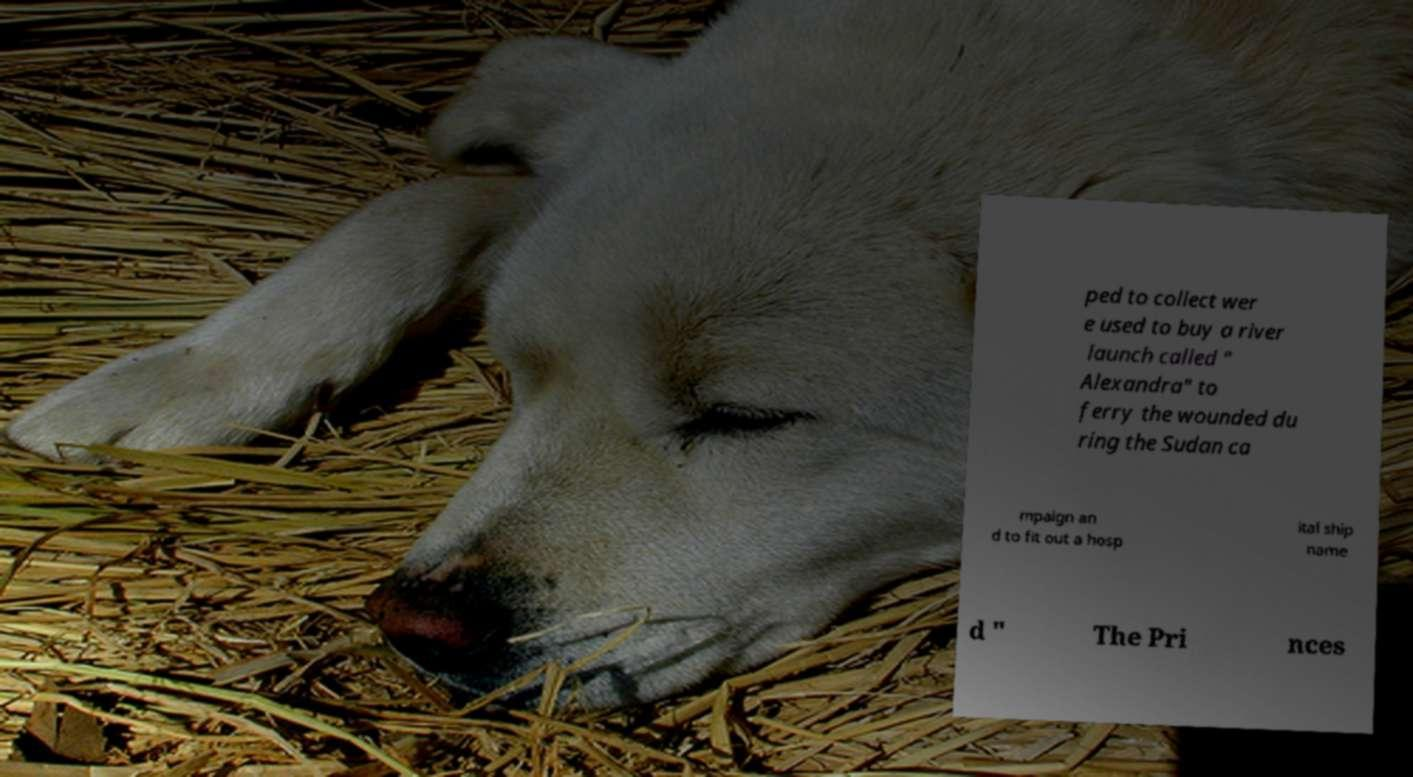Can you accurately transcribe the text from the provided image for me? ped to collect wer e used to buy a river launch called " Alexandra" to ferry the wounded du ring the Sudan ca mpaign an d to fit out a hosp ital ship name d " The Pri nces 